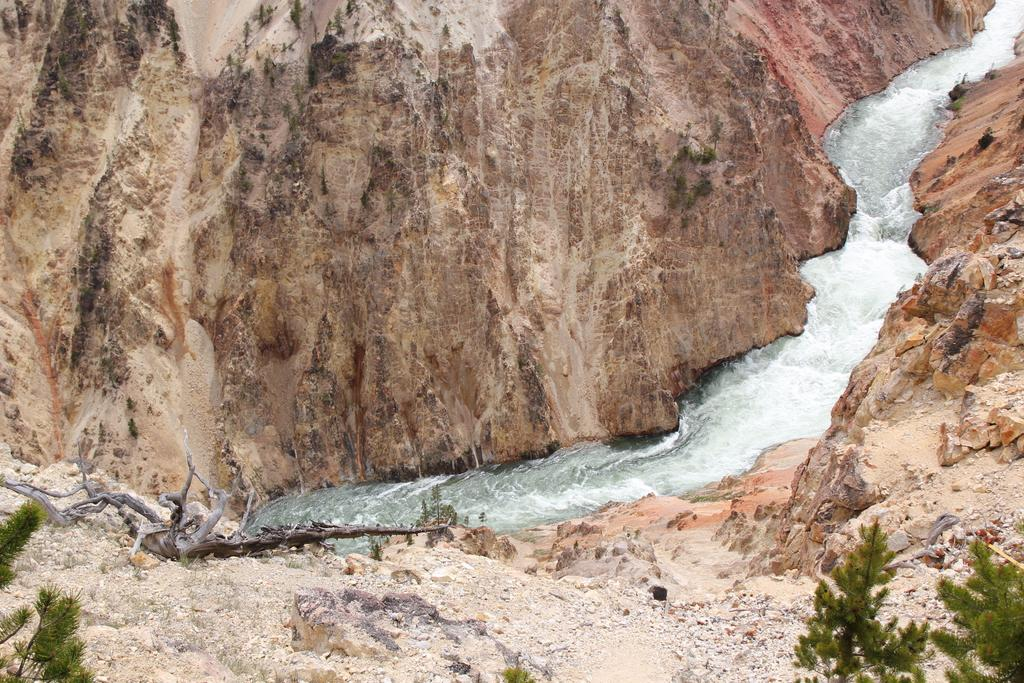What type of landscape is depicted in the image? The image features hills and a river. Where is the river located in the image? The river is flowing in the middle of the image. What type of vegetation can be seen on the right side of the image? There are green color trees on the right side of the image. What type of music can be heard coming from the trees in the image? There is no music present in the image; it is a landscape scene featuring hills, a river, and trees. 